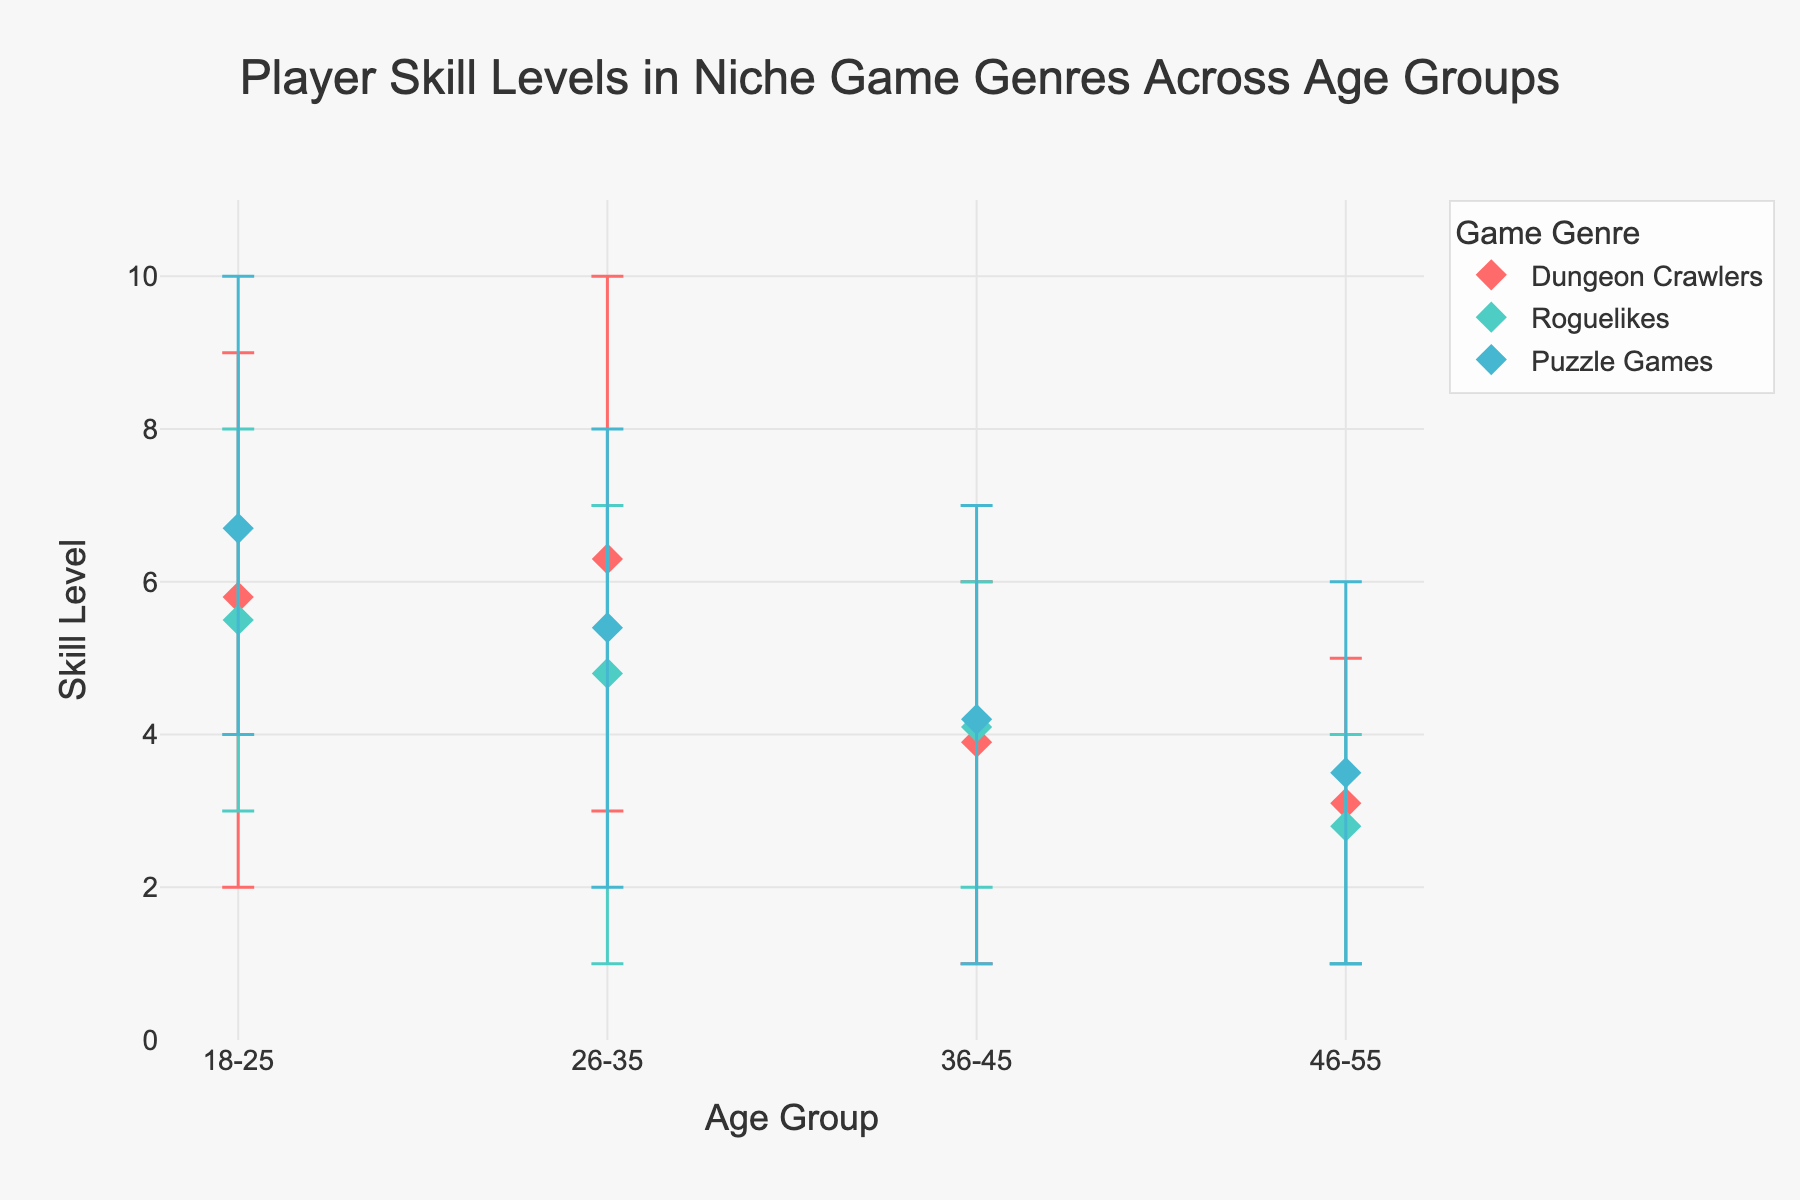What is the title of the figure? The title of the figure is mentioned at the top of the plot.
Answer: Player Skill Levels in Niche Game Genres Across Age Groups Which game genre has the highest mean skill level for the 18-25 age group? By looking at the markers for the 18-25 age group, the highest mean skill level can be observed from the Puzzle Games genre.
Answer: Puzzle Games What is the range of skill levels for Dungeon Crawlers in the 26-35 age group? The plot shows the min and max skill levels using error bars. For Dungeon Crawlers in the 26-35 age group, the min is 3 and the max is 10.
Answer: 3 to 10 What age group has the lowest mean skill level in Roguelikes? By examining the markers for Roguelikes across all age groups, the lowest mean skill level is found in the 46-55 age group.
Answer: 46-55 Which age group has the widest range of skill levels for Puzzle Games? The widest range can be identified by comparing the length of the error bars for Puzzle Games. The 18-25 age group has the widest range with a min of 4 and a max of 10, giving a range of 6.
Answer: 18-25 Is the mean skill level for Roguelikes higher or lower for age group 26-35 compared to age group 36-45? By identifying the mean markers for Roguelikes in the 26-35 and 36-45 age groups, it's observed that the mean for 26-35 is higher.
Answer: Higher How does the mean skill level for Puzzle Games in the 36-45 age group compare to that in the 26-35 age group? The mean skill levels of Puzzle Games for both age groups need to be compared. 36-45 has a mean of 4.2 while 26-35 has a mean of 5.4.
Answer: Lower What is the mean skill level for Dungeon Crawlers in the 36-45 age group? The mean skill level can be directly read from the marker representing Dungeon Crawlers in the 36-45 age group.
Answer: 3.9 Which game genre shows a decrease in mean skill level as age increases? By examining the trend of mean skill levels across age groups for each genre, both Dungeon Crawlers and Roguelikes show decreasing trends.
Answer: Dungeon Crawlers and Roguelikes What is the error range for Puzzle Games in the 46-55 age group? The error range is calculated based on the min and max skill levels provided by the error bars. For Puzzle Games in the 46-55 age group, the min is 1 and the max is 6, giving an error range of 5.
Answer: 5 